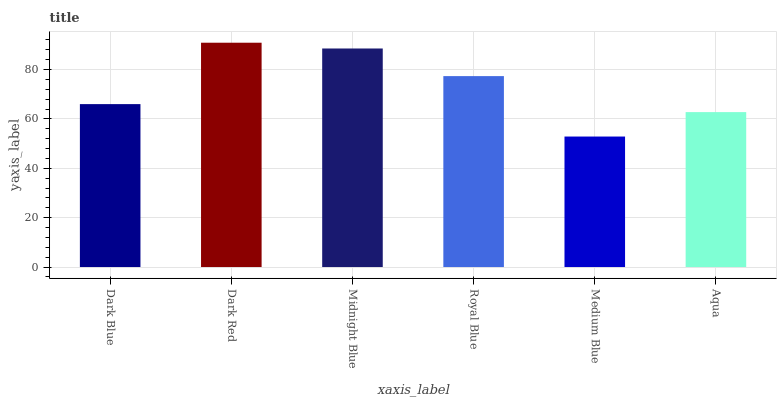Is Medium Blue the minimum?
Answer yes or no. Yes. Is Dark Red the maximum?
Answer yes or no. Yes. Is Midnight Blue the minimum?
Answer yes or no. No. Is Midnight Blue the maximum?
Answer yes or no. No. Is Dark Red greater than Midnight Blue?
Answer yes or no. Yes. Is Midnight Blue less than Dark Red?
Answer yes or no. Yes. Is Midnight Blue greater than Dark Red?
Answer yes or no. No. Is Dark Red less than Midnight Blue?
Answer yes or no. No. Is Royal Blue the high median?
Answer yes or no. Yes. Is Dark Blue the low median?
Answer yes or no. Yes. Is Dark Red the high median?
Answer yes or no. No. Is Medium Blue the low median?
Answer yes or no. No. 